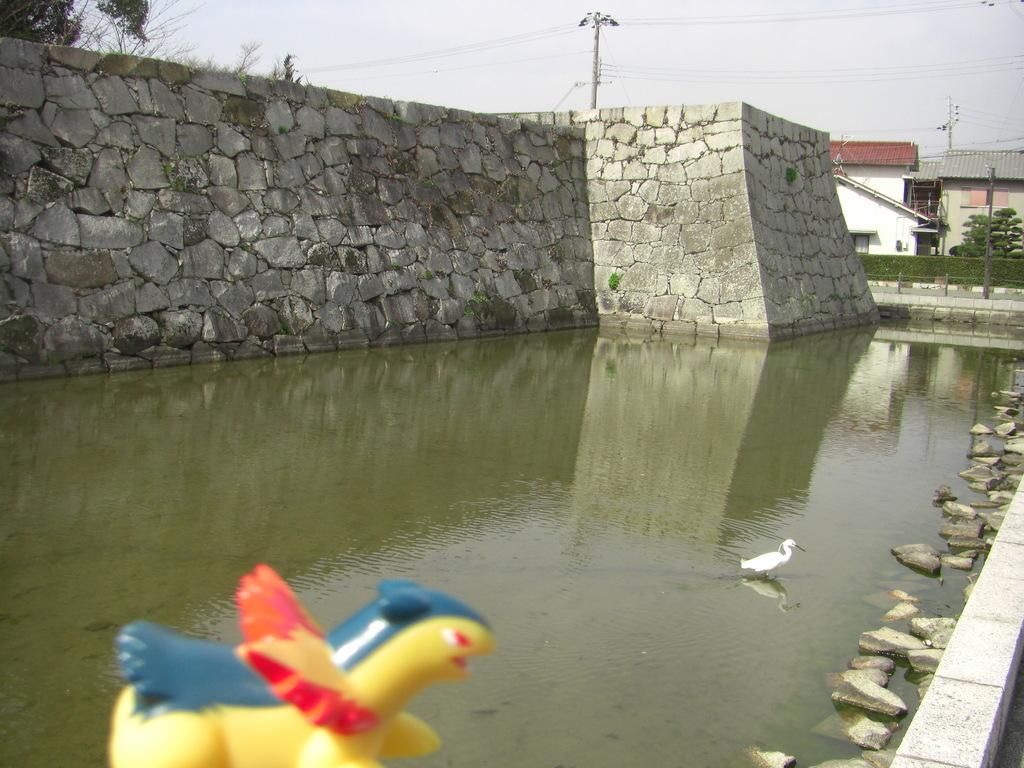What is located in the foreground of the image? There is a toy in the foreground of the image. What is the bird doing in the image? The bird is in the water. What can be seen in the background of the image? There is a wall, houses, electric poles, and wires in the background of the image. What type of paper is being used as a scarf by the oranges in the image? There are no oranges or paper present in the image. 